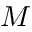Convert formula to latex. <formula><loc_0><loc_0><loc_500><loc_500>M</formula> 